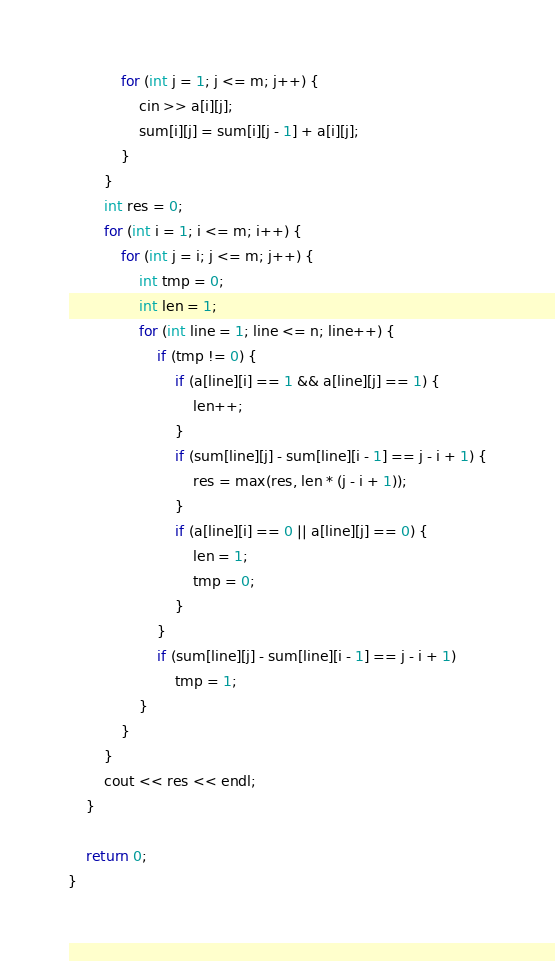Convert code to text. <code><loc_0><loc_0><loc_500><loc_500><_C++_>            for (int j = 1; j <= m; j++) {
                cin >> a[i][j];
                sum[i][j] = sum[i][j - 1] + a[i][j];
            }
        }
        int res = 0;
        for (int i = 1; i <= m; i++) {
            for (int j = i; j <= m; j++) {
                int tmp = 0;
                int len = 1;
                for (int line = 1; line <= n; line++) {
                    if (tmp != 0) {
                        if (a[line][i] == 1 && a[line][j] == 1) {
                            len++;
                        }
                        if (sum[line][j] - sum[line][i - 1] == j - i + 1) {
                            res = max(res, len * (j - i + 1));
                        }
                        if (a[line][i] == 0 || a[line][j] == 0) {
                            len = 1;
                            tmp = 0;
                        }
                    }
                    if (sum[line][j] - sum[line][i - 1] == j - i + 1)
                        tmp = 1;
                }
            }
        }
        cout << res << endl;
    }

    return 0;
}</code> 